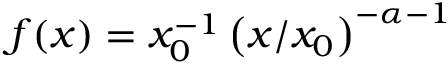Convert formula to latex. <formula><loc_0><loc_0><loc_500><loc_500>f ( x ) = x _ { 0 } ^ { - 1 } \left ( x / x _ { 0 } \right ) ^ { - \alpha - 1 }</formula> 